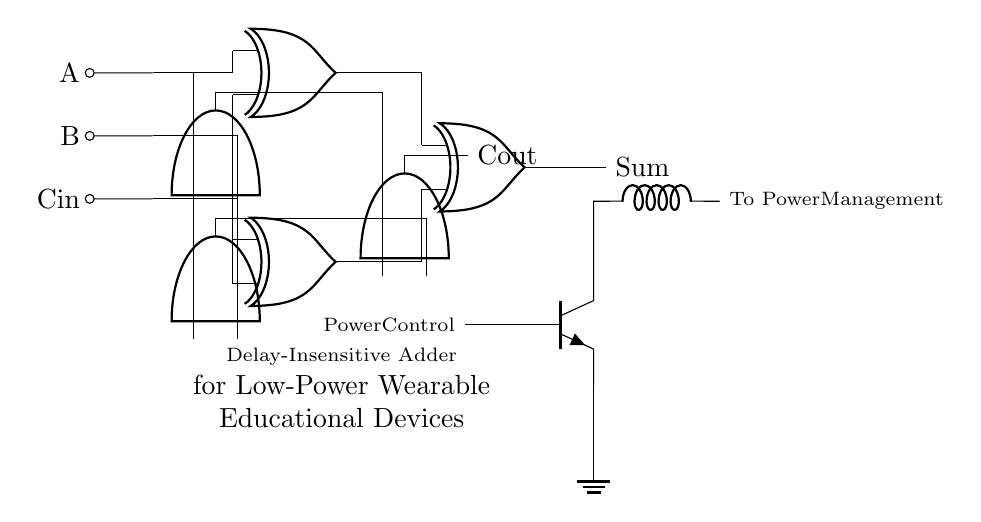What is the function of the circuit? The circuit functions as a delay-insensitive adder, which is designed to perform addition without being affected by the propagation delay of the components, making it suitable for low-power applications.
Answer: Delay-insensitive adder How many Muller C-elements are present in the circuit? There are three Muller C-elements in the circuit, as indicated by the symbols in the diagram that are shaped like a vertical AND gate.
Answer: Three What signals are used as inputs to the adder? The input signals to the adder are A, B, and Cin; these labels are placed next to the respective lines indicating where the signals enter the circuit.
Answer: A, B, Cin What is the purpose of the power-saving component shown in the circuit? The power-saving component, indicated as a transistor, serves to control power usage in the circuit by managing the current flow to the rest of the circuit for efficiency.
Answer: Power control What type of logic gates are used in the circuit? The circuit primarily uses Muller C-elements and XOR gates, which are essential for implementing the addition logic while maintaining delay insensitivity.
Answer: Muller C-elements and XOR gates What is the output of the logic circuit? The outputs of the circuit are "Sum" and "Cout", which represent the result of the addition operation and the carry output, respectively, as indicated by the labels next to the output lines.
Answer: Sum, Cout 